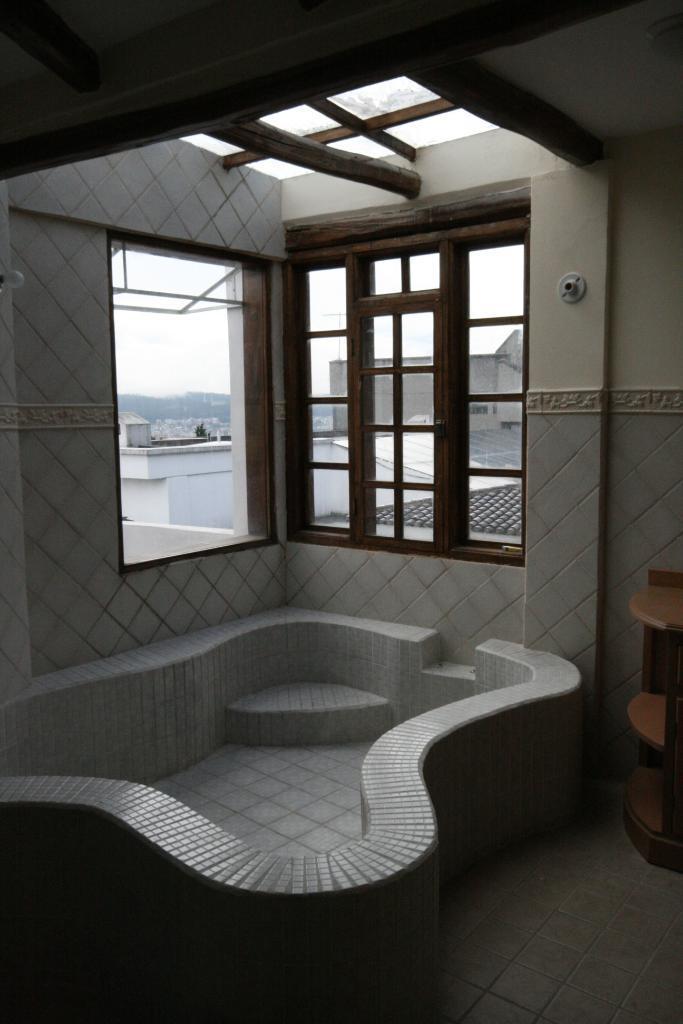Please provide a concise description of this image. In this image I can see a table, windows and number of buildings. I can see this image is inside view of a room. 